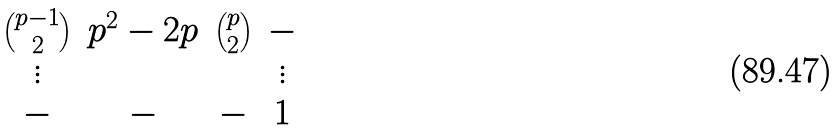<formula> <loc_0><loc_0><loc_500><loc_500>\begin{matrix} \binom { p - 1 } { 2 } & p ^ { 2 } - 2 p & \binom { p } { 2 } & - \\ \vdots & & & \vdots \\ - & - & - & 1 \end{matrix}</formula> 